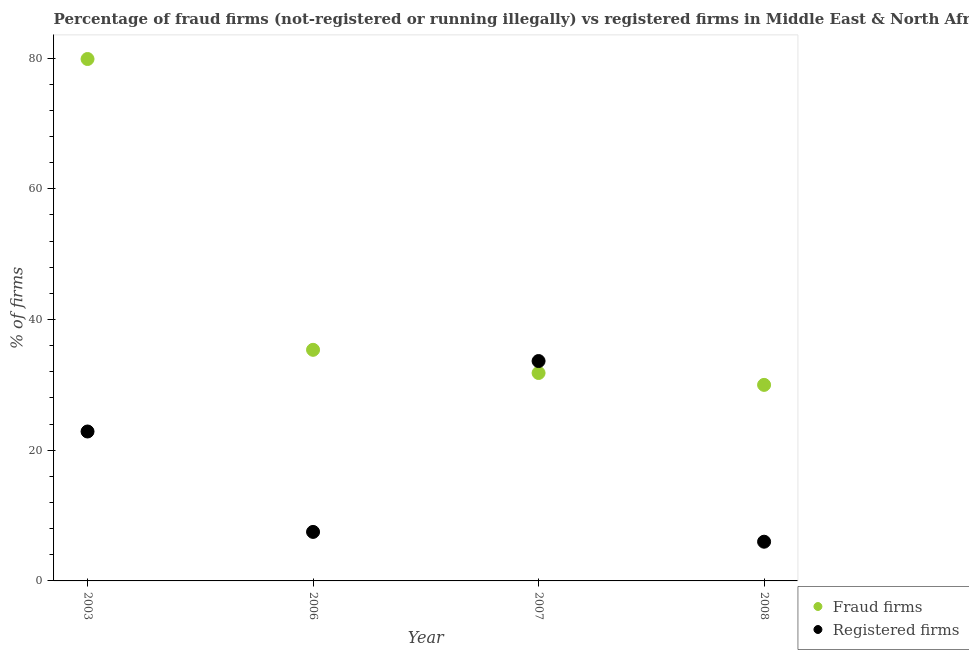Is the number of dotlines equal to the number of legend labels?
Your answer should be very brief. Yes. What is the percentage of registered firms in 2003?
Your response must be concise. 22.87. Across all years, what is the maximum percentage of fraud firms?
Keep it short and to the point. 79.87. What is the total percentage of registered firms in the graph?
Keep it short and to the point. 70.02. What is the difference between the percentage of registered firms in 2006 and that in 2008?
Make the answer very short. 1.5. What is the difference between the percentage of registered firms in 2003 and the percentage of fraud firms in 2008?
Provide a short and direct response. -7.13. What is the average percentage of fraud firms per year?
Make the answer very short. 44.26. What is the ratio of the percentage of fraud firms in 2003 to that in 2007?
Provide a short and direct response. 2.51. What is the difference between the highest and the second highest percentage of registered firms?
Your response must be concise. 10.78. What is the difference between the highest and the lowest percentage of fraud firms?
Your answer should be compact. 49.87. In how many years, is the percentage of fraud firms greater than the average percentage of fraud firms taken over all years?
Your answer should be very brief. 1. Is the sum of the percentage of fraud firms in 2003 and 2007 greater than the maximum percentage of registered firms across all years?
Provide a short and direct response. Yes. What is the difference between two consecutive major ticks on the Y-axis?
Give a very brief answer. 20. Are the values on the major ticks of Y-axis written in scientific E-notation?
Your answer should be very brief. No. Where does the legend appear in the graph?
Offer a terse response. Bottom right. How are the legend labels stacked?
Your response must be concise. Vertical. What is the title of the graph?
Provide a short and direct response. Percentage of fraud firms (not-registered or running illegally) vs registered firms in Middle East & North Africa (developing only). What is the label or title of the X-axis?
Offer a very short reply. Year. What is the label or title of the Y-axis?
Your answer should be very brief. % of firms. What is the % of firms in Fraud firms in 2003?
Offer a very short reply. 79.87. What is the % of firms in Registered firms in 2003?
Ensure brevity in your answer.  22.87. What is the % of firms of Fraud firms in 2006?
Offer a terse response. 35.37. What is the % of firms of Fraud firms in 2007?
Ensure brevity in your answer.  31.82. What is the % of firms of Registered firms in 2007?
Your answer should be very brief. 33.65. What is the % of firms in Fraud firms in 2008?
Make the answer very short. 30. What is the % of firms of Registered firms in 2008?
Your answer should be very brief. 6. Across all years, what is the maximum % of firms in Fraud firms?
Your response must be concise. 79.87. Across all years, what is the maximum % of firms of Registered firms?
Offer a very short reply. 33.65. Across all years, what is the minimum % of firms in Fraud firms?
Keep it short and to the point. 30. Across all years, what is the minimum % of firms of Registered firms?
Provide a short and direct response. 6. What is the total % of firms of Fraud firms in the graph?
Ensure brevity in your answer.  177.06. What is the total % of firms of Registered firms in the graph?
Ensure brevity in your answer.  70.02. What is the difference between the % of firms in Fraud firms in 2003 and that in 2006?
Offer a very short reply. 44.5. What is the difference between the % of firms in Registered firms in 2003 and that in 2006?
Provide a short and direct response. 15.37. What is the difference between the % of firms in Fraud firms in 2003 and that in 2007?
Ensure brevity in your answer.  48.05. What is the difference between the % of firms of Registered firms in 2003 and that in 2007?
Give a very brief answer. -10.78. What is the difference between the % of firms of Fraud firms in 2003 and that in 2008?
Provide a succinct answer. 49.87. What is the difference between the % of firms in Registered firms in 2003 and that in 2008?
Make the answer very short. 16.87. What is the difference between the % of firms in Fraud firms in 2006 and that in 2007?
Your response must be concise. 3.55. What is the difference between the % of firms of Registered firms in 2006 and that in 2007?
Give a very brief answer. -26.15. What is the difference between the % of firms of Fraud firms in 2006 and that in 2008?
Make the answer very short. 5.37. What is the difference between the % of firms of Registered firms in 2006 and that in 2008?
Give a very brief answer. 1.5. What is the difference between the % of firms in Fraud firms in 2007 and that in 2008?
Offer a very short reply. 1.82. What is the difference between the % of firms of Registered firms in 2007 and that in 2008?
Keep it short and to the point. 27.65. What is the difference between the % of firms of Fraud firms in 2003 and the % of firms of Registered firms in 2006?
Ensure brevity in your answer.  72.37. What is the difference between the % of firms in Fraud firms in 2003 and the % of firms in Registered firms in 2007?
Offer a terse response. 46.22. What is the difference between the % of firms in Fraud firms in 2003 and the % of firms in Registered firms in 2008?
Offer a very short reply. 73.87. What is the difference between the % of firms of Fraud firms in 2006 and the % of firms of Registered firms in 2007?
Make the answer very short. 1.72. What is the difference between the % of firms of Fraud firms in 2006 and the % of firms of Registered firms in 2008?
Provide a short and direct response. 29.37. What is the difference between the % of firms in Fraud firms in 2007 and the % of firms in Registered firms in 2008?
Provide a succinct answer. 25.82. What is the average % of firms of Fraud firms per year?
Provide a short and direct response. 44.26. What is the average % of firms in Registered firms per year?
Your answer should be compact. 17.5. In the year 2003, what is the difference between the % of firms in Fraud firms and % of firms in Registered firms?
Make the answer very short. 57. In the year 2006, what is the difference between the % of firms of Fraud firms and % of firms of Registered firms?
Offer a very short reply. 27.87. In the year 2007, what is the difference between the % of firms in Fraud firms and % of firms in Registered firms?
Provide a succinct answer. -1.83. What is the ratio of the % of firms of Fraud firms in 2003 to that in 2006?
Keep it short and to the point. 2.26. What is the ratio of the % of firms of Registered firms in 2003 to that in 2006?
Your response must be concise. 3.05. What is the ratio of the % of firms of Fraud firms in 2003 to that in 2007?
Give a very brief answer. 2.51. What is the ratio of the % of firms in Registered firms in 2003 to that in 2007?
Keep it short and to the point. 0.68. What is the ratio of the % of firms in Fraud firms in 2003 to that in 2008?
Offer a very short reply. 2.66. What is the ratio of the % of firms of Registered firms in 2003 to that in 2008?
Provide a short and direct response. 3.81. What is the ratio of the % of firms in Fraud firms in 2006 to that in 2007?
Keep it short and to the point. 1.11. What is the ratio of the % of firms of Registered firms in 2006 to that in 2007?
Offer a terse response. 0.22. What is the ratio of the % of firms in Fraud firms in 2006 to that in 2008?
Your response must be concise. 1.18. What is the ratio of the % of firms of Registered firms in 2006 to that in 2008?
Your answer should be compact. 1.25. What is the ratio of the % of firms in Fraud firms in 2007 to that in 2008?
Keep it short and to the point. 1.06. What is the ratio of the % of firms of Registered firms in 2007 to that in 2008?
Keep it short and to the point. 5.61. What is the difference between the highest and the second highest % of firms of Fraud firms?
Your answer should be compact. 44.5. What is the difference between the highest and the second highest % of firms of Registered firms?
Ensure brevity in your answer.  10.78. What is the difference between the highest and the lowest % of firms of Fraud firms?
Your answer should be compact. 49.87. What is the difference between the highest and the lowest % of firms in Registered firms?
Offer a very short reply. 27.65. 